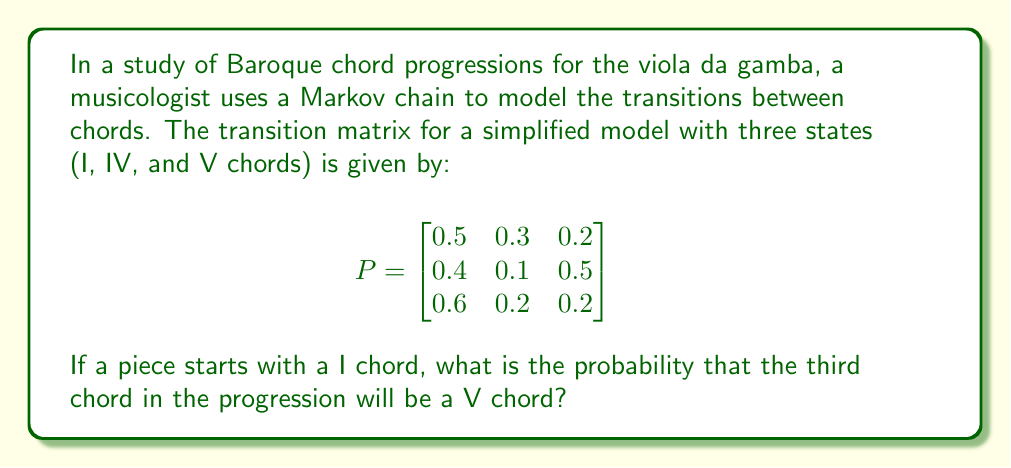Provide a solution to this math problem. To solve this problem, we need to use the properties of Markov chains and matrix multiplication. Let's approach this step-by-step:

1) We start with the initial state vector $\mathbf{v}_0 = [1, 0, 0]$, representing that we begin with a I chord.

2) To find the probability distribution after one transition, we multiply $\mathbf{v}_0$ by the transition matrix $P$:

   $\mathbf{v}_1 = \mathbf{v}_0 P = [1, 0, 0] \begin{bmatrix}
   0.5 & 0.3 & 0.2 \\
   0.4 & 0.1 & 0.5 \\
   0.6 & 0.2 & 0.2
   \end{bmatrix} = [0.5, 0.3, 0.2]$

3) To find the probability distribution for the third chord, we need to multiply $\mathbf{v}_1$ by $P$ again:

   $\mathbf{v}_2 = \mathbf{v}_1 P = [0.5, 0.3, 0.2] \begin{bmatrix}
   0.5 & 0.3 & 0.2 \\
   0.4 & 0.1 & 0.5 \\
   0.6 & 0.2 & 0.2
   \end{bmatrix}$

4) Let's perform this multiplication:
   
   $\mathbf{v}_2 = [(0.5 \times 0.5 + 0.3 \times 0.4 + 0.2 \times 0.6), (0.5 \times 0.3 + 0.3 \times 0.1 + 0.2 \times 0.2), (0.5 \times 0.2 + 0.3 \times 0.5 + 0.2 \times 0.2)]$

5) Simplifying:
   
   $\mathbf{v}_2 = [0.49, 0.22, 0.29]$

6) The probability of the third chord being a V chord is the third element of $\mathbf{v}_2$, which is 0.29 or 29%.
Answer: 0.29 